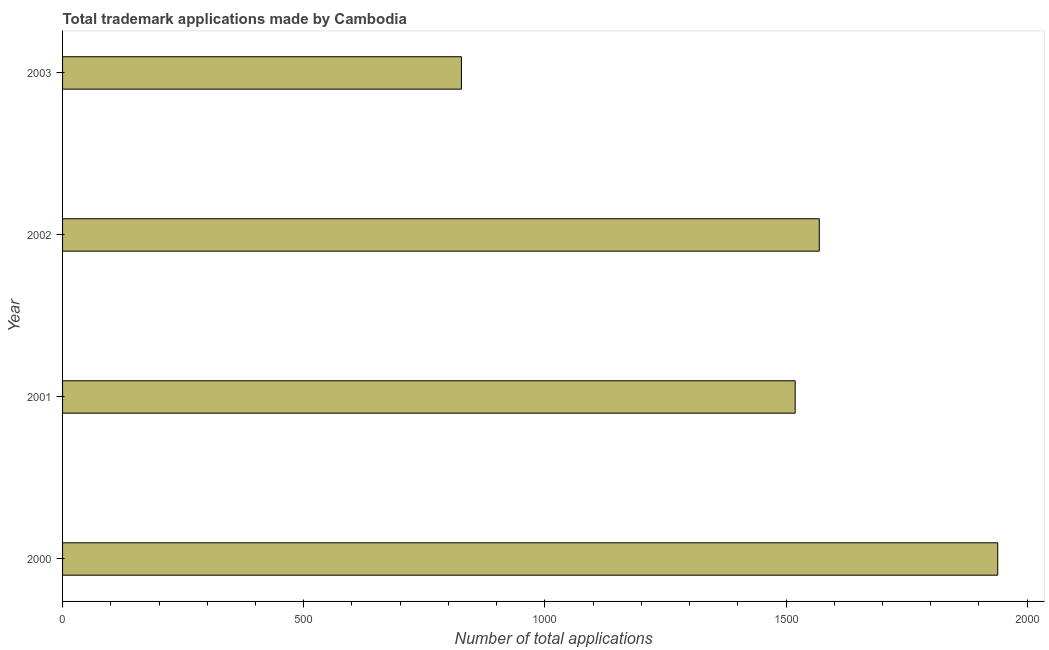Does the graph contain any zero values?
Ensure brevity in your answer.  No. What is the title of the graph?
Offer a terse response. Total trademark applications made by Cambodia. What is the label or title of the X-axis?
Offer a very short reply. Number of total applications. What is the label or title of the Y-axis?
Offer a very short reply. Year. What is the number of trademark applications in 2003?
Your answer should be compact. 827. Across all years, what is the maximum number of trademark applications?
Make the answer very short. 1939. Across all years, what is the minimum number of trademark applications?
Your response must be concise. 827. In which year was the number of trademark applications maximum?
Provide a succinct answer. 2000. In which year was the number of trademark applications minimum?
Give a very brief answer. 2003. What is the sum of the number of trademark applications?
Your answer should be compact. 5854. What is the difference between the number of trademark applications in 2001 and 2002?
Ensure brevity in your answer.  -50. What is the average number of trademark applications per year?
Your answer should be very brief. 1463. What is the median number of trademark applications?
Your answer should be compact. 1544. Do a majority of the years between 2000 and 2001 (inclusive) have number of trademark applications greater than 300 ?
Offer a terse response. Yes. What is the ratio of the number of trademark applications in 2002 to that in 2003?
Your answer should be compact. 1.9. Is the number of trademark applications in 2000 less than that in 2001?
Provide a succinct answer. No. What is the difference between the highest and the second highest number of trademark applications?
Ensure brevity in your answer.  370. What is the difference between the highest and the lowest number of trademark applications?
Provide a succinct answer. 1112. How many bars are there?
Your answer should be very brief. 4. Are all the bars in the graph horizontal?
Ensure brevity in your answer.  Yes. How many years are there in the graph?
Provide a short and direct response. 4. What is the difference between two consecutive major ticks on the X-axis?
Ensure brevity in your answer.  500. What is the Number of total applications of 2000?
Provide a succinct answer. 1939. What is the Number of total applications of 2001?
Provide a succinct answer. 1519. What is the Number of total applications of 2002?
Your answer should be very brief. 1569. What is the Number of total applications of 2003?
Give a very brief answer. 827. What is the difference between the Number of total applications in 2000 and 2001?
Ensure brevity in your answer.  420. What is the difference between the Number of total applications in 2000 and 2002?
Give a very brief answer. 370. What is the difference between the Number of total applications in 2000 and 2003?
Ensure brevity in your answer.  1112. What is the difference between the Number of total applications in 2001 and 2003?
Give a very brief answer. 692. What is the difference between the Number of total applications in 2002 and 2003?
Make the answer very short. 742. What is the ratio of the Number of total applications in 2000 to that in 2001?
Your answer should be compact. 1.28. What is the ratio of the Number of total applications in 2000 to that in 2002?
Provide a succinct answer. 1.24. What is the ratio of the Number of total applications in 2000 to that in 2003?
Your answer should be very brief. 2.35. What is the ratio of the Number of total applications in 2001 to that in 2003?
Give a very brief answer. 1.84. What is the ratio of the Number of total applications in 2002 to that in 2003?
Keep it short and to the point. 1.9. 